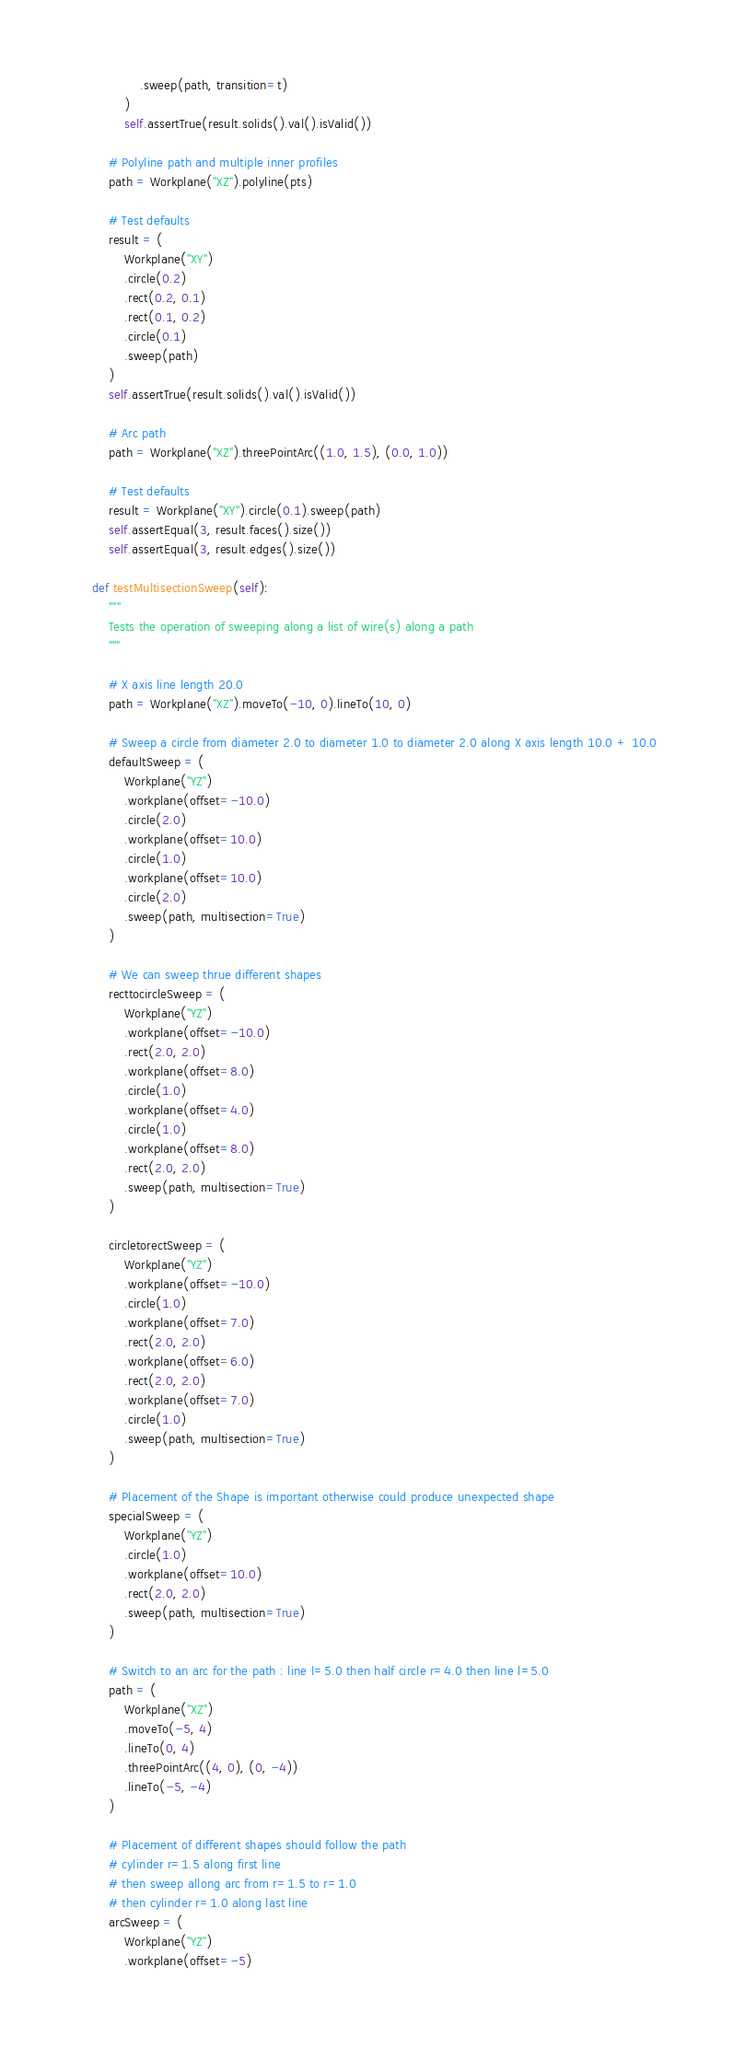Convert code to text. <code><loc_0><loc_0><loc_500><loc_500><_Python_>                .sweep(path, transition=t)
            )
            self.assertTrue(result.solids().val().isValid())

        # Polyline path and multiple inner profiles
        path = Workplane("XZ").polyline(pts)

        # Test defaults
        result = (
            Workplane("XY")
            .circle(0.2)
            .rect(0.2, 0.1)
            .rect(0.1, 0.2)
            .circle(0.1)
            .sweep(path)
        )
        self.assertTrue(result.solids().val().isValid())

        # Arc path
        path = Workplane("XZ").threePointArc((1.0, 1.5), (0.0, 1.0))

        # Test defaults
        result = Workplane("XY").circle(0.1).sweep(path)
        self.assertEqual(3, result.faces().size())
        self.assertEqual(3, result.edges().size())

    def testMultisectionSweep(self):
        """
        Tests the operation of sweeping along a list of wire(s) along a path
        """

        # X axis line length 20.0
        path = Workplane("XZ").moveTo(-10, 0).lineTo(10, 0)

        # Sweep a circle from diameter 2.0 to diameter 1.0 to diameter 2.0 along X axis length 10.0 + 10.0
        defaultSweep = (
            Workplane("YZ")
            .workplane(offset=-10.0)
            .circle(2.0)
            .workplane(offset=10.0)
            .circle(1.0)
            .workplane(offset=10.0)
            .circle(2.0)
            .sweep(path, multisection=True)
        )

        # We can sweep thrue different shapes
        recttocircleSweep = (
            Workplane("YZ")
            .workplane(offset=-10.0)
            .rect(2.0, 2.0)
            .workplane(offset=8.0)
            .circle(1.0)
            .workplane(offset=4.0)
            .circle(1.0)
            .workplane(offset=8.0)
            .rect(2.0, 2.0)
            .sweep(path, multisection=True)
        )

        circletorectSweep = (
            Workplane("YZ")
            .workplane(offset=-10.0)
            .circle(1.0)
            .workplane(offset=7.0)
            .rect(2.0, 2.0)
            .workplane(offset=6.0)
            .rect(2.0, 2.0)
            .workplane(offset=7.0)
            .circle(1.0)
            .sweep(path, multisection=True)
        )

        # Placement of the Shape is important otherwise could produce unexpected shape
        specialSweep = (
            Workplane("YZ")
            .circle(1.0)
            .workplane(offset=10.0)
            .rect(2.0, 2.0)
            .sweep(path, multisection=True)
        )

        # Switch to an arc for the path : line l=5.0 then half circle r=4.0 then line l=5.0
        path = (
            Workplane("XZ")
            .moveTo(-5, 4)
            .lineTo(0, 4)
            .threePointArc((4, 0), (0, -4))
            .lineTo(-5, -4)
        )

        # Placement of different shapes should follow the path
        # cylinder r=1.5 along first line
        # then sweep allong arc from r=1.5 to r=1.0
        # then cylinder r=1.0 along last line
        arcSweep = (
            Workplane("YZ")
            .workplane(offset=-5)</code> 